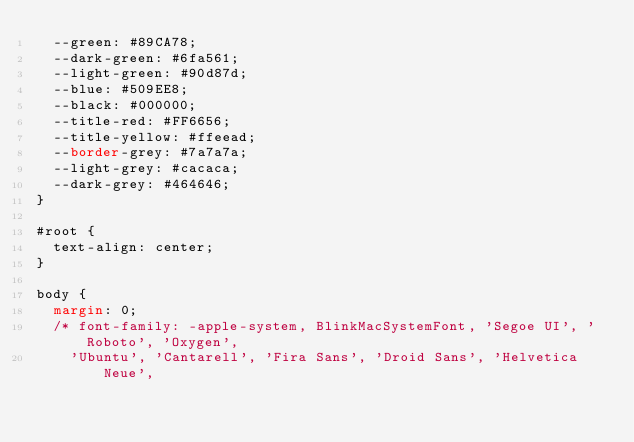Convert code to text. <code><loc_0><loc_0><loc_500><loc_500><_CSS_>  --green: #89CA78;
  --dark-green: #6fa561;
  --light-green: #90d87d;
  --blue: #509EE8;
  --black: #000000;
  --title-red: #FF6656;
  --title-yellow: #ffeead;
  --border-grey: #7a7a7a;
  --light-grey: #cacaca;
  --dark-grey: #464646;
}

#root {
  text-align: center;
}

body {
  margin: 0;
  /* font-family: -apple-system, BlinkMacSystemFont, 'Segoe UI', 'Roboto', 'Oxygen',
    'Ubuntu', 'Cantarell', 'Fira Sans', 'Droid Sans', 'Helvetica Neue',</code> 